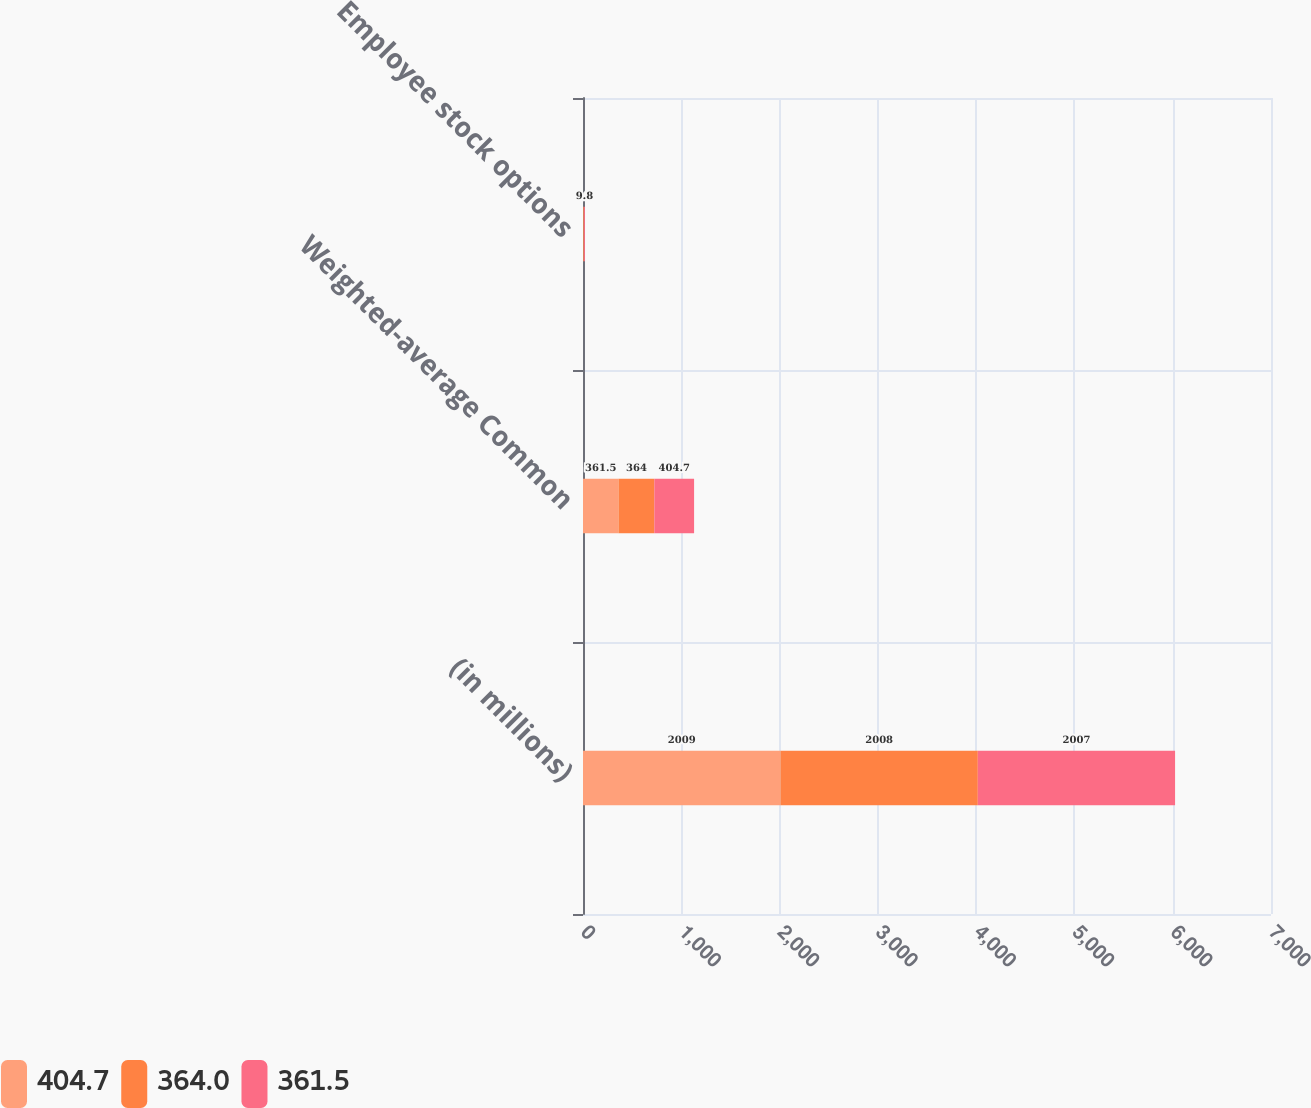<chart> <loc_0><loc_0><loc_500><loc_500><stacked_bar_chart><ecel><fcel>(in millions)<fcel>Weighted-average Common<fcel>Employee stock options<nl><fcel>404.7<fcel>2009<fcel>361.5<fcel>3.9<nl><fcel>364<fcel>2008<fcel>364<fcel>5.8<nl><fcel>361.5<fcel>2007<fcel>404.7<fcel>9.8<nl></chart> 